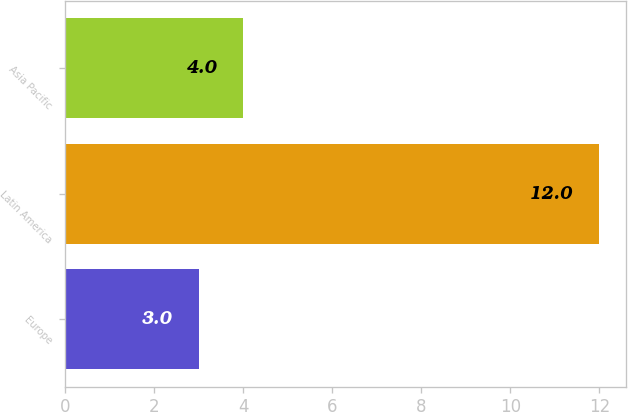<chart> <loc_0><loc_0><loc_500><loc_500><bar_chart><fcel>Europe<fcel>Latin America<fcel>Asia Pacific<nl><fcel>3<fcel>12<fcel>4<nl></chart> 